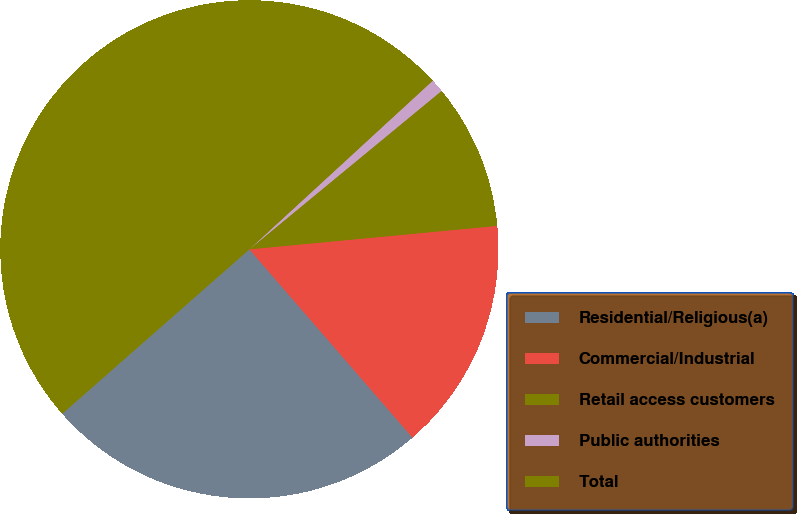<chart> <loc_0><loc_0><loc_500><loc_500><pie_chart><fcel>Residential/Religious(a)<fcel>Commercial/Industrial<fcel>Retail access customers<fcel>Public authorities<fcel>Total<nl><fcel>24.89%<fcel>15.14%<fcel>9.47%<fcel>0.86%<fcel>49.64%<nl></chart> 